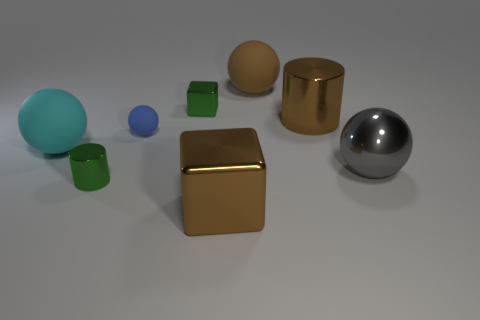What is the size of the green thing that is on the right side of the cylinder to the left of the brown rubber thing?
Provide a short and direct response. Small. What number of blocks are small purple things or big rubber objects?
Give a very brief answer. 0. What color is the metal block that is the same size as the gray object?
Keep it short and to the point. Brown. The big brown metal thing right of the matte thing on the right side of the brown shiny cube is what shape?
Your answer should be compact. Cylinder. There is a green object that is in front of the gray object; does it have the same size as the cyan object?
Your answer should be very brief. No. What number of other things are the same material as the tiny blue thing?
Make the answer very short. 2. What number of yellow things are large shiny balls or metallic objects?
Keep it short and to the point. 0. What is the size of the metallic object that is the same color as the small cylinder?
Offer a very short reply. Small. What number of small things are behind the large gray metal thing?
Your answer should be compact. 2. There is a metallic block that is behind the large brown shiny cube that is in front of the big ball on the left side of the big brown ball; what size is it?
Your response must be concise. Small. 